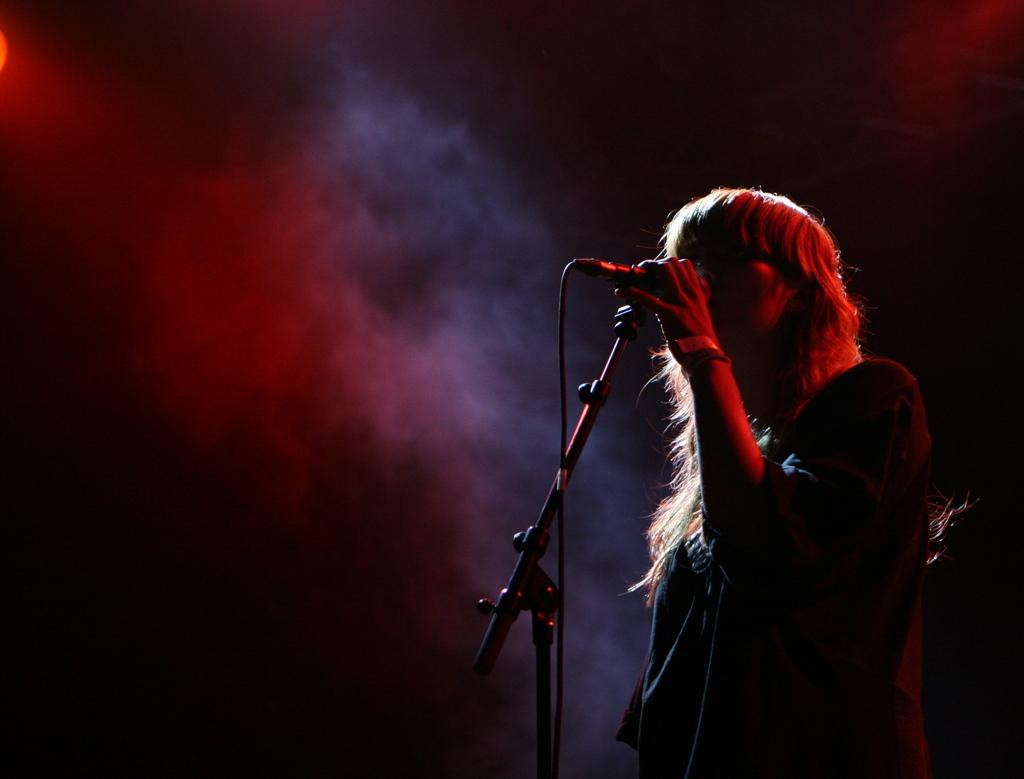Who is the main subject in the image? There is a woman in the image. What is the woman doing in the image? The woman is standing and holding a microphone with a stand. What can be seen in the background of the image? There is smoke visible in the background of the image. Where is the table located in the image? There is no table present in the image. What type of locket is the woman wearing in the image? The woman is not wearing a locket in the image. 